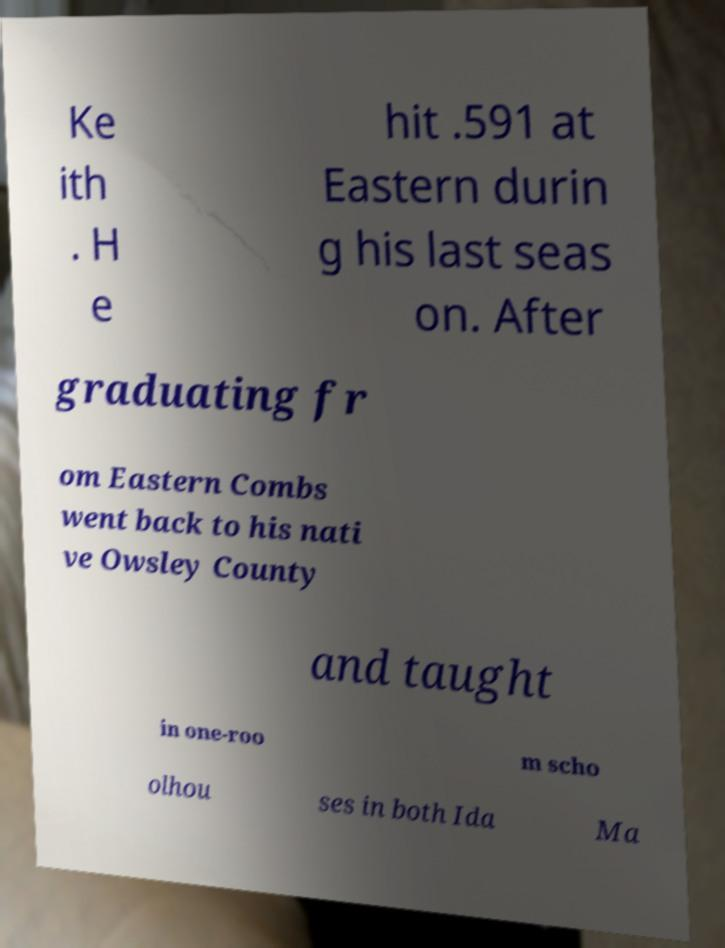Please identify and transcribe the text found in this image. Ke ith . H e hit .591 at Eastern durin g his last seas on. After graduating fr om Eastern Combs went back to his nati ve Owsley County and taught in one-roo m scho olhou ses in both Ida Ma 